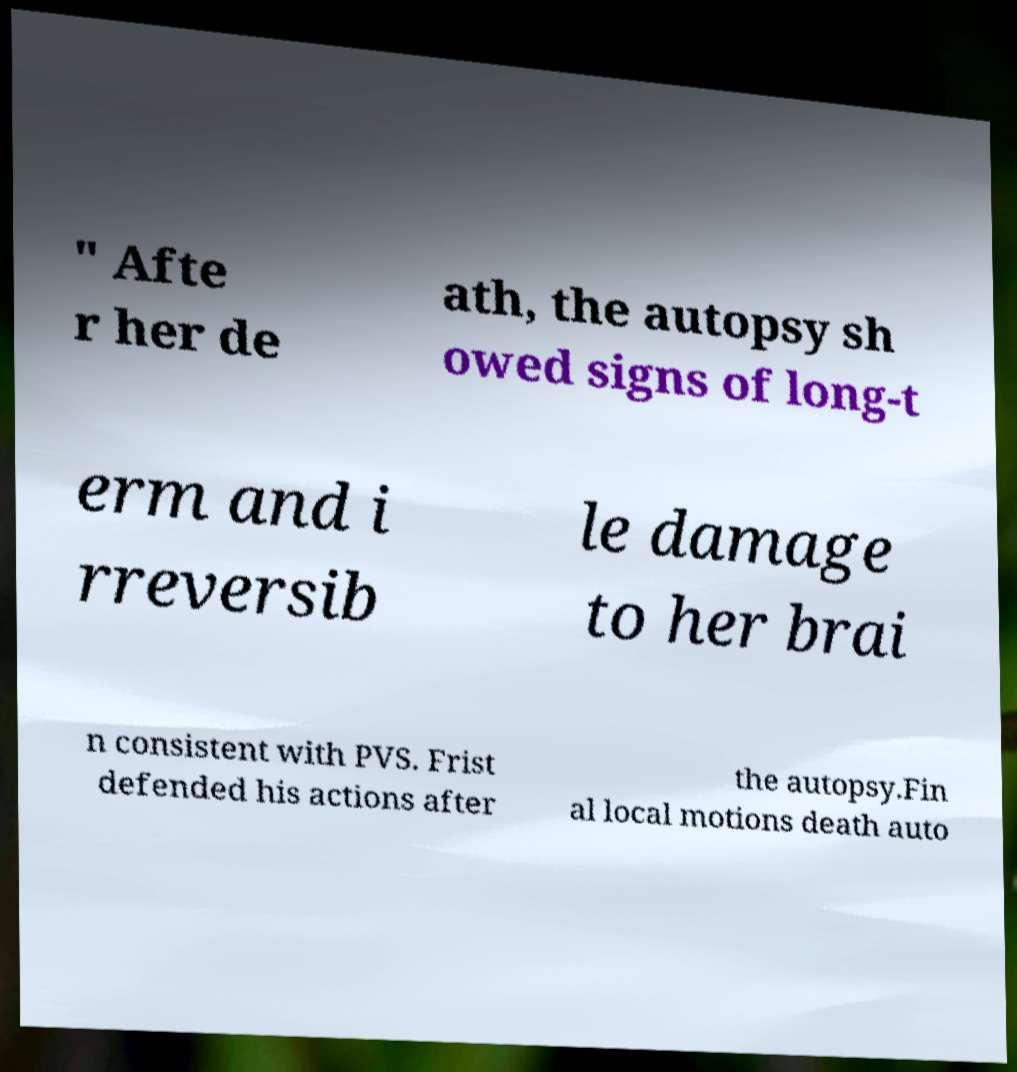Could you extract and type out the text from this image? " Afte r her de ath, the autopsy sh owed signs of long-t erm and i rreversib le damage to her brai n consistent with PVS. Frist defended his actions after the autopsy.Fin al local motions death auto 